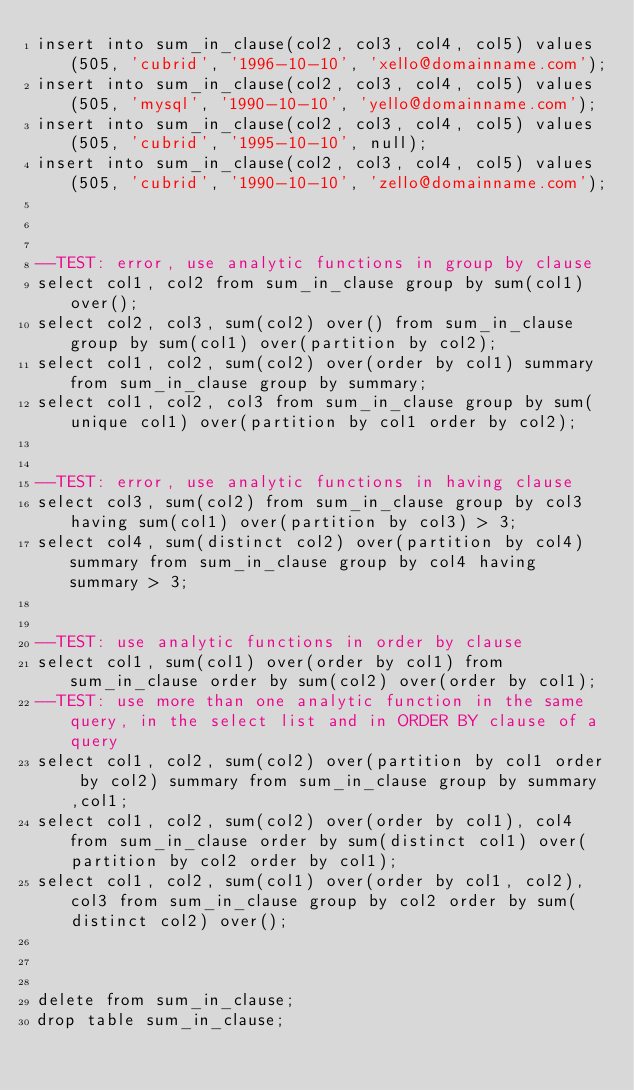<code> <loc_0><loc_0><loc_500><loc_500><_SQL_>insert into sum_in_clause(col2, col3, col4, col5) values(505, 'cubrid', '1996-10-10', 'xello@domainname.com');
insert into sum_in_clause(col2, col3, col4, col5) values(505, 'mysql', '1990-10-10', 'yello@domainname.com');
insert into sum_in_clause(col2, col3, col4, col5) values(505, 'cubrid', '1995-10-10', null);
insert into sum_in_clause(col2, col3, col4, col5) values(505, 'cubrid', '1990-10-10', 'zello@domainname.com');



--TEST: error, use analytic functions in group by clause
select col1, col2 from sum_in_clause group by sum(col1) over();
select col2, col3, sum(col2) over() from sum_in_clause group by sum(col1) over(partition by col2);
select col1, col2, sum(col2) over(order by col1) summary from sum_in_clause group by summary;
select col1, col2, col3 from sum_in_clause group by sum(unique col1) over(partition by col1 order by col2);


--TEST: error, use analytic functions in having clause
select col3, sum(col2) from sum_in_clause group by col3 having sum(col1) over(partition by col3) > 3;
select col4, sum(distinct col2) over(partition by col4) summary from sum_in_clause group by col4 having summary > 3;


--TEST: use analytic functions in order by clause
select col1, sum(col1) over(order by col1) from sum_in_clause order by sum(col2) over(order by col1);
--TEST: use more than one analytic function in the same query, in the select list and in ORDER BY clause of a query
select col1, col2, sum(col2) over(partition by col1 order by col2) summary from sum_in_clause group by summary ,col1;
select col1, col2, sum(col2) over(order by col1), col4 from sum_in_clause order by sum(distinct col1) over(partition by col2 order by col1);
select col1, col2, sum(col1) over(order by col1, col2), col3 from sum_in_clause group by col2 order by sum(distinct col2) over();



delete from sum_in_clause;
drop table sum_in_clause;


</code> 